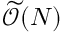Convert formula to latex. <formula><loc_0><loc_0><loc_500><loc_500>\widetilde { \mathcal { O } } ( N )</formula> 